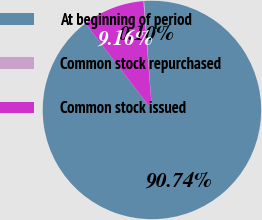Convert chart. <chart><loc_0><loc_0><loc_500><loc_500><pie_chart><fcel>At beginning of period<fcel>Common stock repurchased<fcel>Common stock issued<nl><fcel>90.73%<fcel>0.1%<fcel>9.16%<nl></chart> 